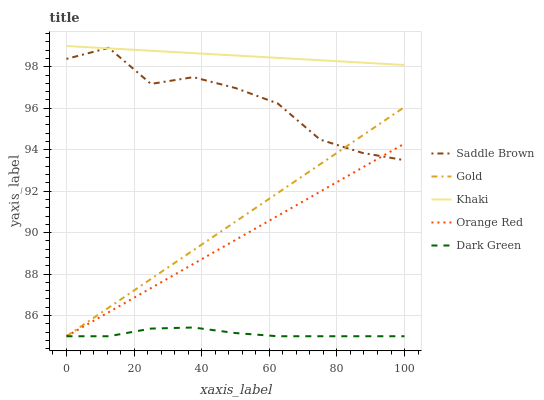Does Dark Green have the minimum area under the curve?
Answer yes or no. Yes. Does Khaki have the maximum area under the curve?
Answer yes or no. Yes. Does Saddle Brown have the minimum area under the curve?
Answer yes or no. No. Does Saddle Brown have the maximum area under the curve?
Answer yes or no. No. Is Khaki the smoothest?
Answer yes or no. Yes. Is Saddle Brown the roughest?
Answer yes or no. Yes. Is Saddle Brown the smoothest?
Answer yes or no. No. Is Khaki the roughest?
Answer yes or no. No. Does Dark Green have the lowest value?
Answer yes or no. Yes. Does Saddle Brown have the lowest value?
Answer yes or no. No. Does Khaki have the highest value?
Answer yes or no. Yes. Does Saddle Brown have the highest value?
Answer yes or no. No. Is Dark Green less than Saddle Brown?
Answer yes or no. Yes. Is Saddle Brown greater than Dark Green?
Answer yes or no. Yes. Does Orange Red intersect Saddle Brown?
Answer yes or no. Yes. Is Orange Red less than Saddle Brown?
Answer yes or no. No. Is Orange Red greater than Saddle Brown?
Answer yes or no. No. Does Dark Green intersect Saddle Brown?
Answer yes or no. No. 